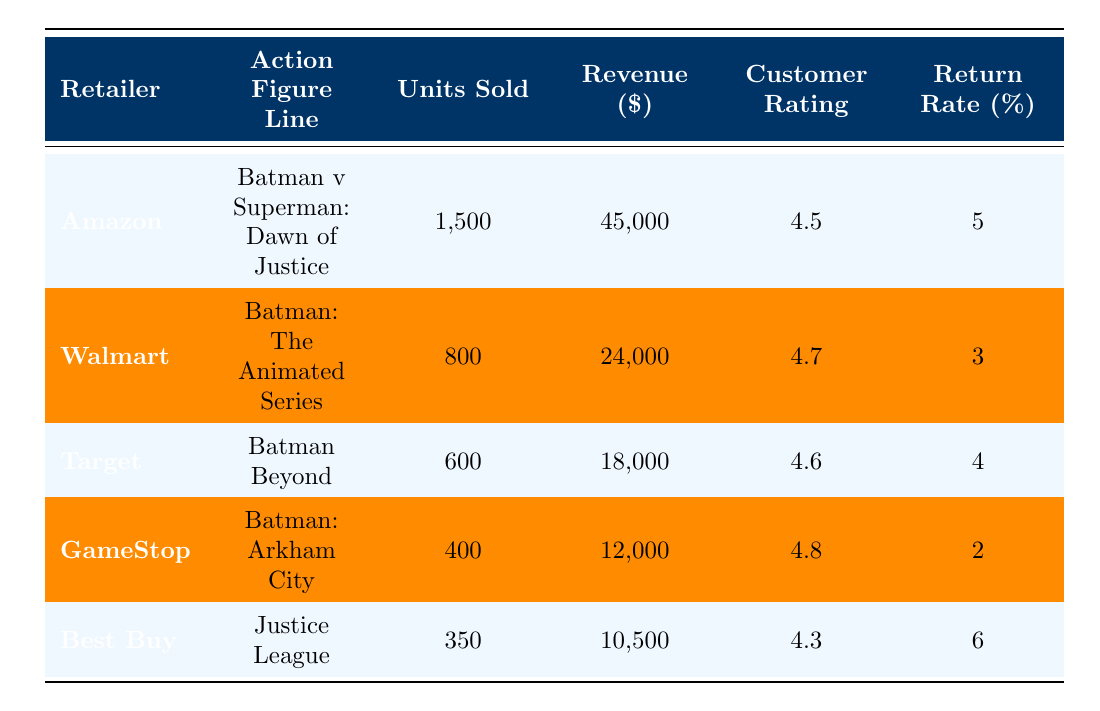What retailer sold the highest number of Batman action figures? Looking at the "Units Sold" column, Amazon has the highest units sold, totaling 1500.
Answer: Amazon Which action figure line had the lowest revenue? By comparing the "Revenue" column, Best Buy's "Justice League" line generated the least revenue at 10500.
Answer: Justice League What is the average customer rating across all retailers? The customer ratings are 4.5, 4.7, 4.6, 4.8, and 4.3. To find the average, we add them up: 4.5 + 4.7 + 4.6 + 4.8 + 4.3 = 24.9. Then, divide by 5 (the number of entries) which equals 4.98.
Answer: 4.98 Is the return rate for the Batman: Arkham City line greater than 3%? The return rate for Batman: Arkham City is 2%, which is less than 3%, so the answer is no.
Answer: No What is the total number of units sold across all retailers? The total units sold can be calculated by summing the "Units Sold" column: 1500 + 800 + 600 + 400 + 350 = 3650 units.
Answer: 3650 units Did any retailer have a return rate of at least 5%? By checking the "Return Rate" column, Amazon and Best Buy have rates of 5% and 6% respectively, confirming that at least one retailer meets this condition.
Answer: Yes Which action figure line had the highest customer rating? The highest customer rating is 4.8 for the action figure line "Batman: Arkham City," according to the "Customer Rating" column.
Answer: Batman: Arkham City How does the revenue of Target compare to that of GameStop? Target's revenue is 18000 and GameStop's is 12000. By comparing these values, Target generates more revenue by 6000, indicating higher performance.
Answer: 6000 more for Target What percentage of units sold does Best Buy represent among all retailers? Best Buy sold 350 units out of a total of 3650 units. To find the percentage, calculate (350/3650) * 100, which is approximately 9.59%.
Answer: 9.59% 